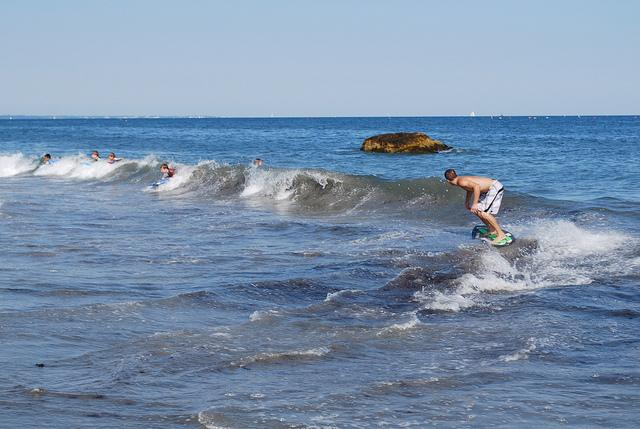Who is the most famous surfer? Please explain your reasoning. duke. The most famous world's surfer is duke. 